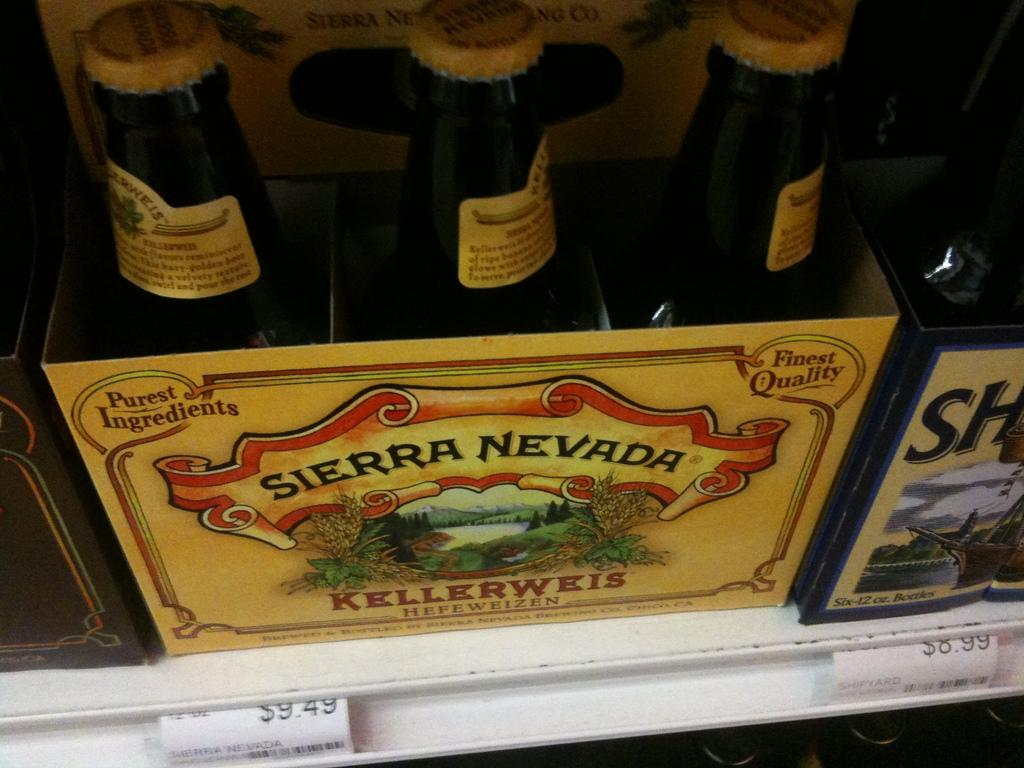Provide a one-sentence caption for the provided image. the six pack of Sierra Nevada is $9.49. 